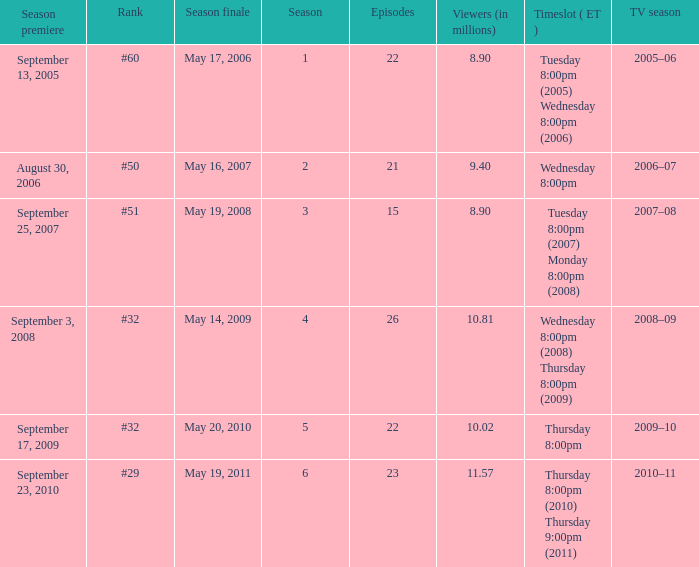What tv season was episode 23 broadcast? 2010–11. 